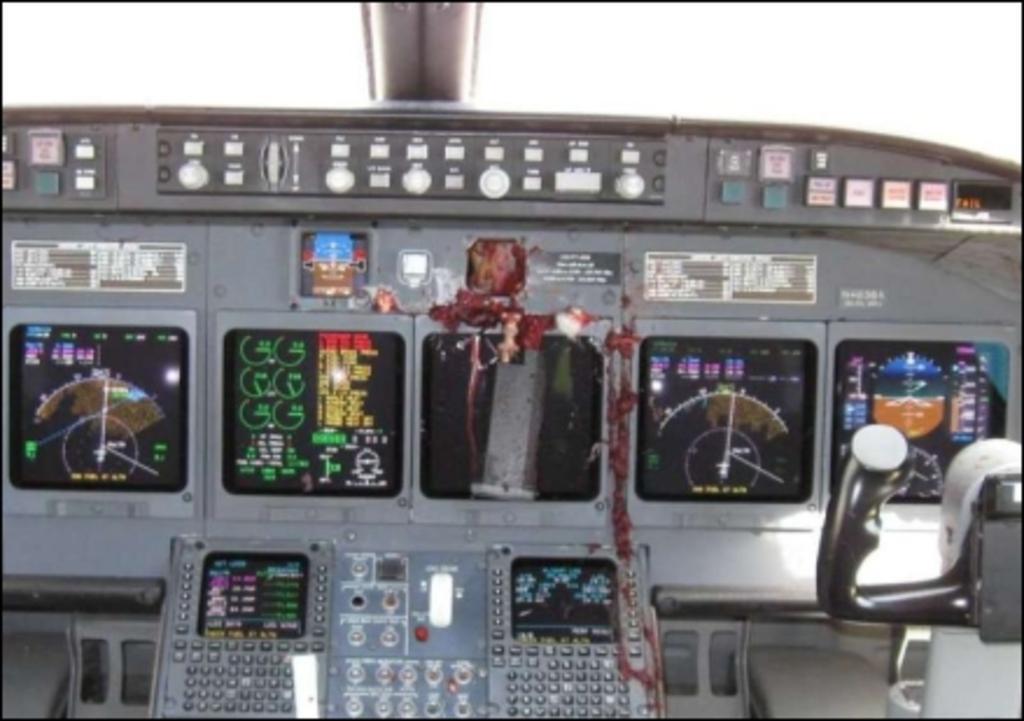In one or two sentences, can you explain what this image depicts? On the right side, there is a controller, on dashboard of an aircraft. In which, there are display boards, buttons, lights and other objects. And the background is white in color. 